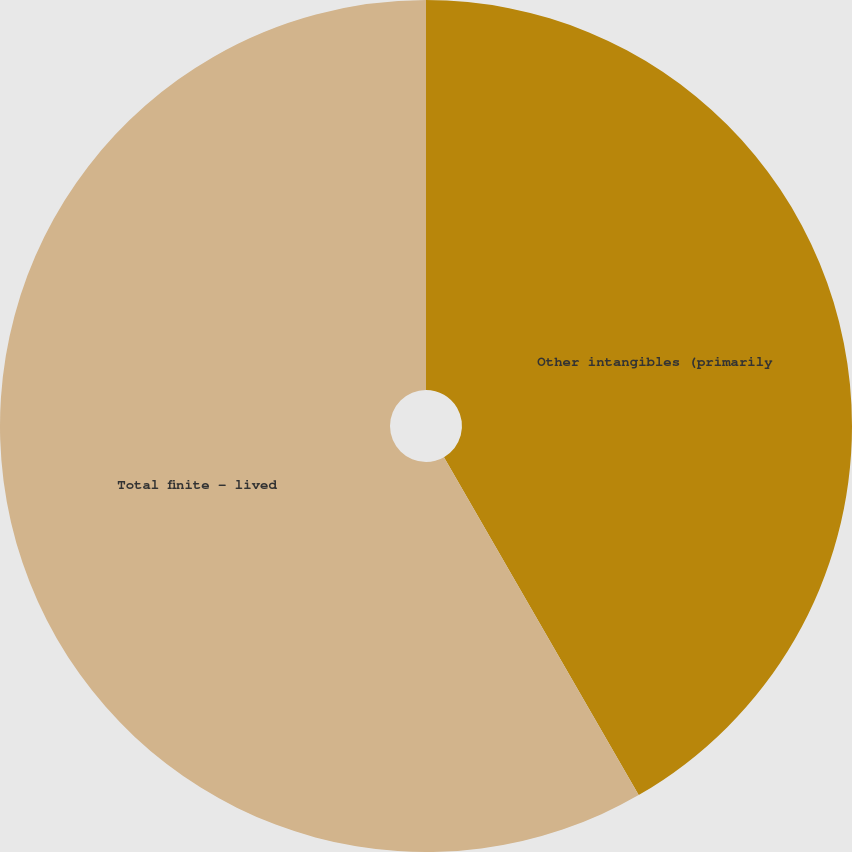<chart> <loc_0><loc_0><loc_500><loc_500><pie_chart><fcel>Other intangibles (primarily<fcel>Total finite - lived<nl><fcel>41.68%<fcel>58.32%<nl></chart> 